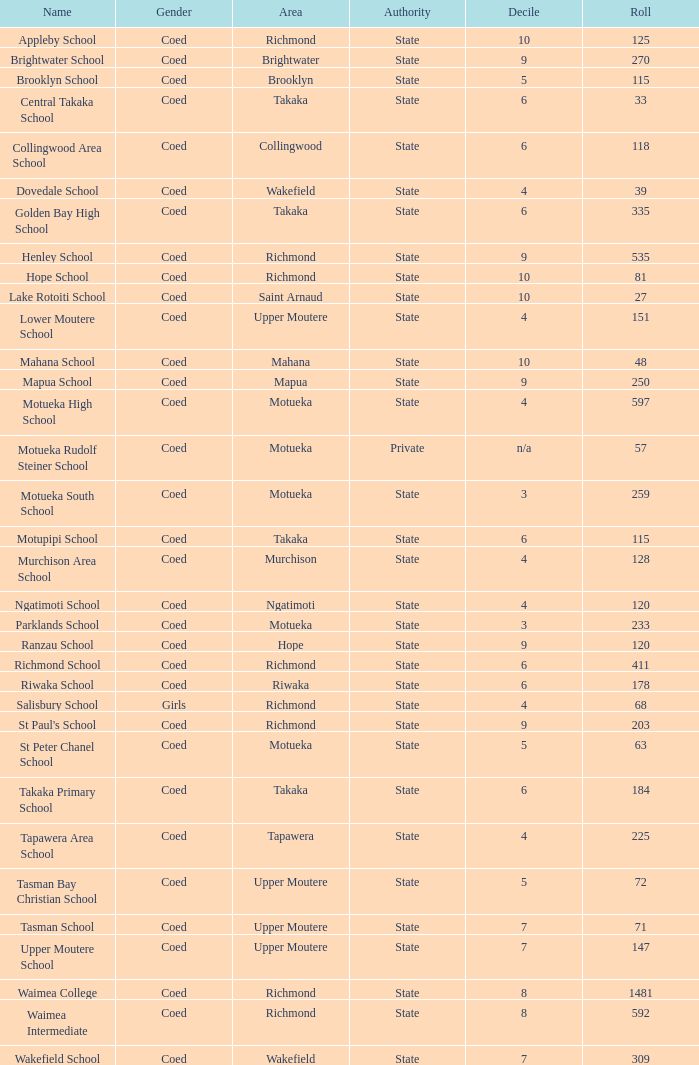What area is Central Takaka School in? Takaka. 